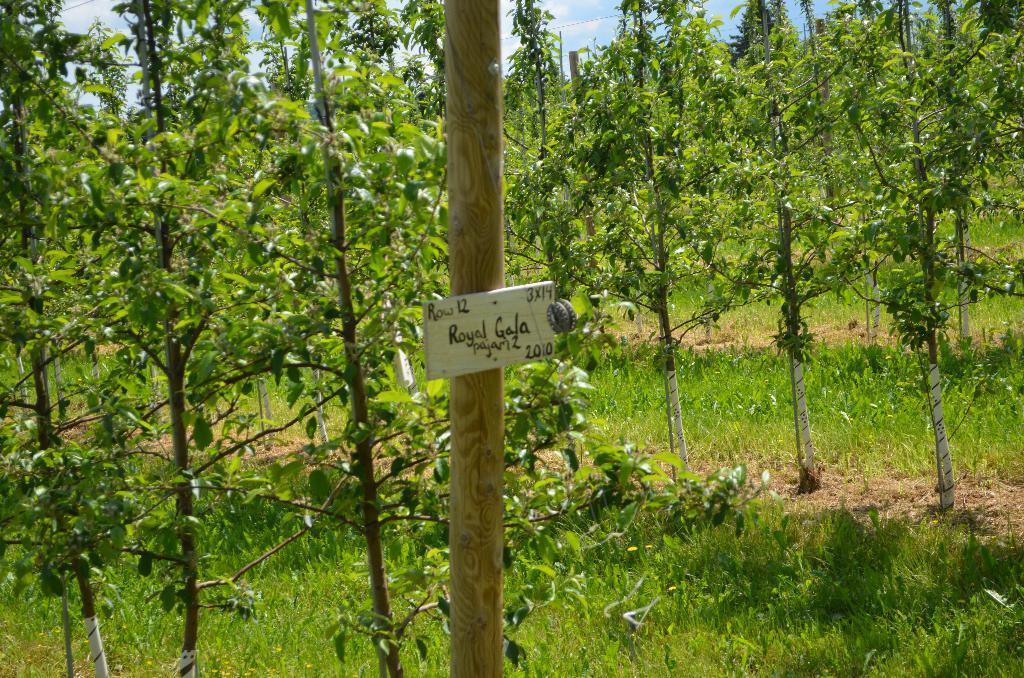How would you summarize this image in a sentence or two? In the foreground of this image, there is a board to a pole. In the background, there are trees, grass, sky and the cloud. 